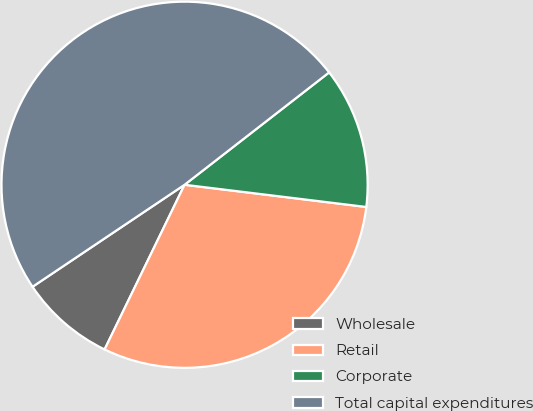Convert chart to OTSL. <chart><loc_0><loc_0><loc_500><loc_500><pie_chart><fcel>Wholesale<fcel>Retail<fcel>Corporate<fcel>Total capital expenditures<nl><fcel>8.4%<fcel>30.26%<fcel>12.45%<fcel>48.89%<nl></chart> 